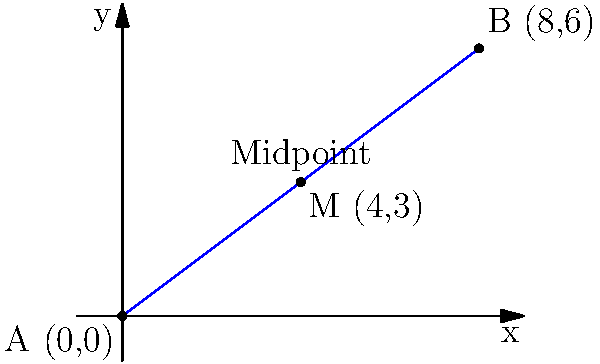As an Information Security Consultant, you're tasked with securing communication between two data centers. The first data center is located at coordinates (0,0) and the second at (8,6) on a secure network map. To optimize network traffic and implement a load balancer, you need to find the coordinates of the midpoint between these two data centers. What are the coordinates of this midpoint? To find the midpoint of a line segment connecting two points, we use the midpoint formula:

$$ M_x = \frac{x_1 + x_2}{2}, M_y = \frac{y_1 + y_2}{2} $$

Where $(x_1, y_1)$ are the coordinates of the first point and $(x_2, y_2)$ are the coordinates of the second point.

Given:
- Data center A: $(0, 0)$
- Data center B: $(8, 6)$

Step 1: Calculate the x-coordinate of the midpoint
$$ M_x = \frac{0 + 8}{2} = \frac{8}{2} = 4 $$

Step 2: Calculate the y-coordinate of the midpoint
$$ M_y = \frac{0 + 6}{2} = \frac{6}{2} = 3 $$

Therefore, the coordinates of the midpoint M are (4, 3).

This midpoint represents the optimal location for placing a load balancer or a relay point to efficiently manage network traffic between the two data centers.
Answer: (4, 3) 